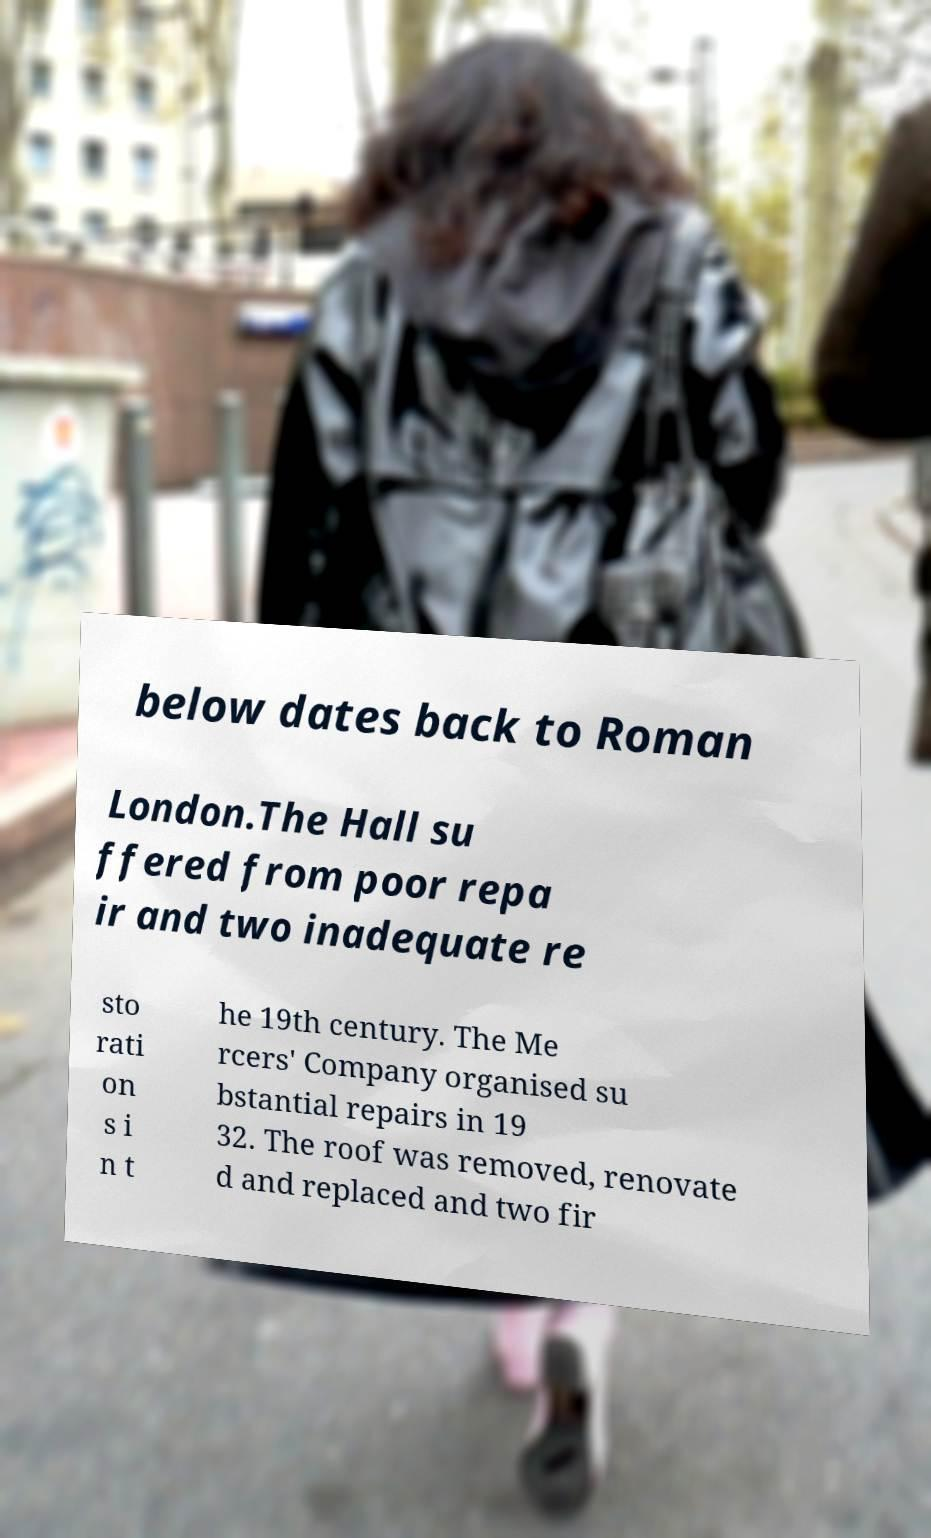For documentation purposes, I need the text within this image transcribed. Could you provide that? below dates back to Roman London.The Hall su ffered from poor repa ir and two inadequate re sto rati on s i n t he 19th century. The Me rcers' Company organised su bstantial repairs in 19 32. The roof was removed, renovate d and replaced and two fir 